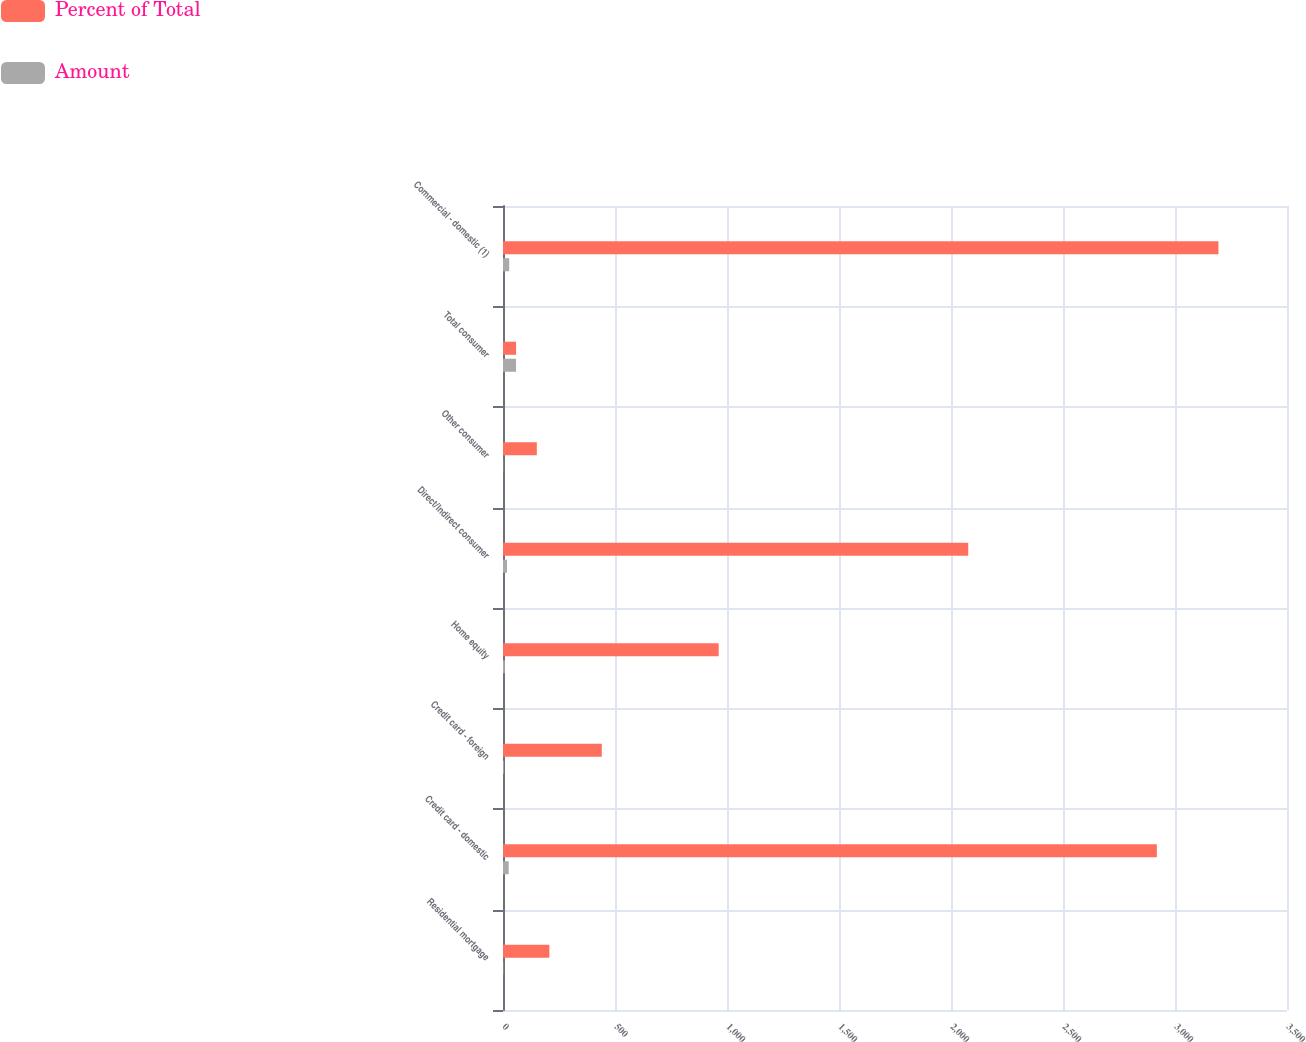<chart> <loc_0><loc_0><loc_500><loc_500><stacked_bar_chart><ecel><fcel>Residential mortgage<fcel>Credit card - domestic<fcel>Credit card - foreign<fcel>Home equity<fcel>Direct/Indirect consumer<fcel>Other consumer<fcel>Total consumer<fcel>Commercial - domestic (1)<nl><fcel>Percent of Total<fcel>207<fcel>2919<fcel>441<fcel>963<fcel>2077<fcel>151<fcel>58.3<fcel>3194<nl><fcel>Amount<fcel>1.8<fcel>25.2<fcel>3.8<fcel>8.3<fcel>17.9<fcel>1.3<fcel>58.3<fcel>27.6<nl></chart> 